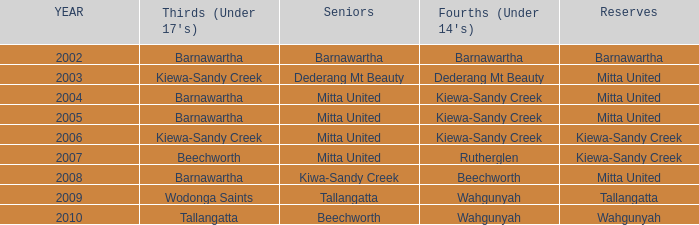Which seniors have a year after 2005, a Reserve of kiewa-sandy creek, and Fourths (Under 14's) of kiewa-sandy creek? Mitta United. 